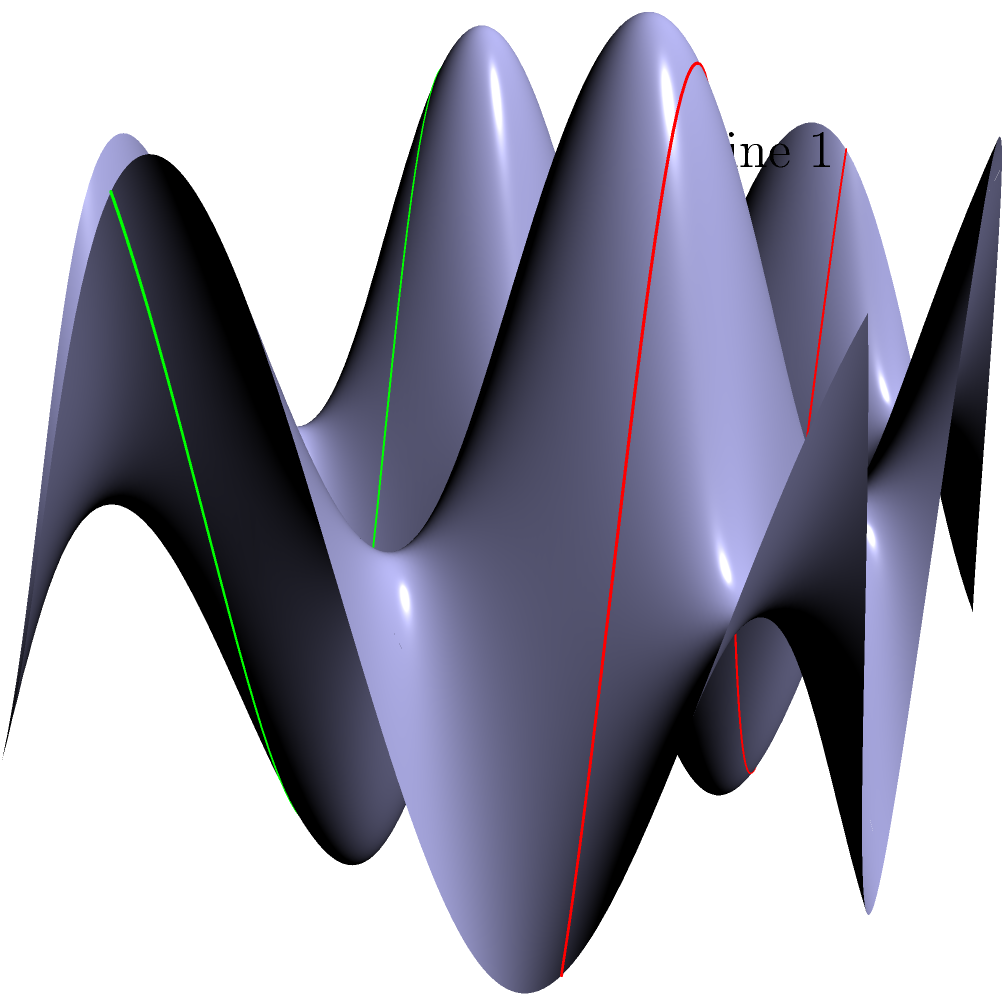In the context of modeling fish scales using a saddle-shaped surface, consider two parallel lines on a flat plane that are mapped onto this non-Euclidean surface. If the distance between these lines at $x=0$ is 2 units, what happens to the distance between them as $x$ approaches infinity? To understand this problem, let's follow these steps:

1) In Euclidean geometry, parallel lines maintain a constant distance. However, on a non-Euclidean surface like our saddle-shaped model, this property doesn't hold.

2) The surface is described by the function $z = 0.5 \sin(2x) \sin(2y)$. This creates a saddle shape that repeats indefinitely in both x and y directions.

3) The two lines are initially parallel on the flat plane, separated by 2 units along the y-axis. They are mapped onto our surface at $y=1$ and $y=-1$.

4) The z-coordinate for each line is given by:
   Line 1: $z_1 = 0.5 \sin(2x) \sin(2)$
   Line 2: $z_2 = 0.5 \sin(2x) \sin(-2) = -0.5 \sin(2x) \sin(2)$

5) The distance between the lines at any point x is not just the difference in y (which remains 2), but we need to consider the z-coordinate as well.

6) The vertical distance in z between the lines is:
   $\Delta z = z_1 - z_2 = 0.5 \sin(2x) \sin(2) - (-0.5 \sin(2x) \sin(2)) = \sin(2x) \sin(2)$

7) As x approaches infinity, $\sin(2x)$ oscillates between -1 and 1. This means $\Delta z$ will oscillate between $-\sin(2)$ and $\sin(2)$.

8) The total distance between the lines at any point is $\sqrt{2^2 + (\Delta z)^2}$, which will oscillate between 2 and $\sqrt{4 + \sin^2(2)}$ as x approaches infinity.

Therefore, as x approaches infinity, the distance between the lines doesn't remain constant but oscillates between these two values.
Answer: Oscillates between 2 and $\sqrt{4 + \sin^2(2)}$ 